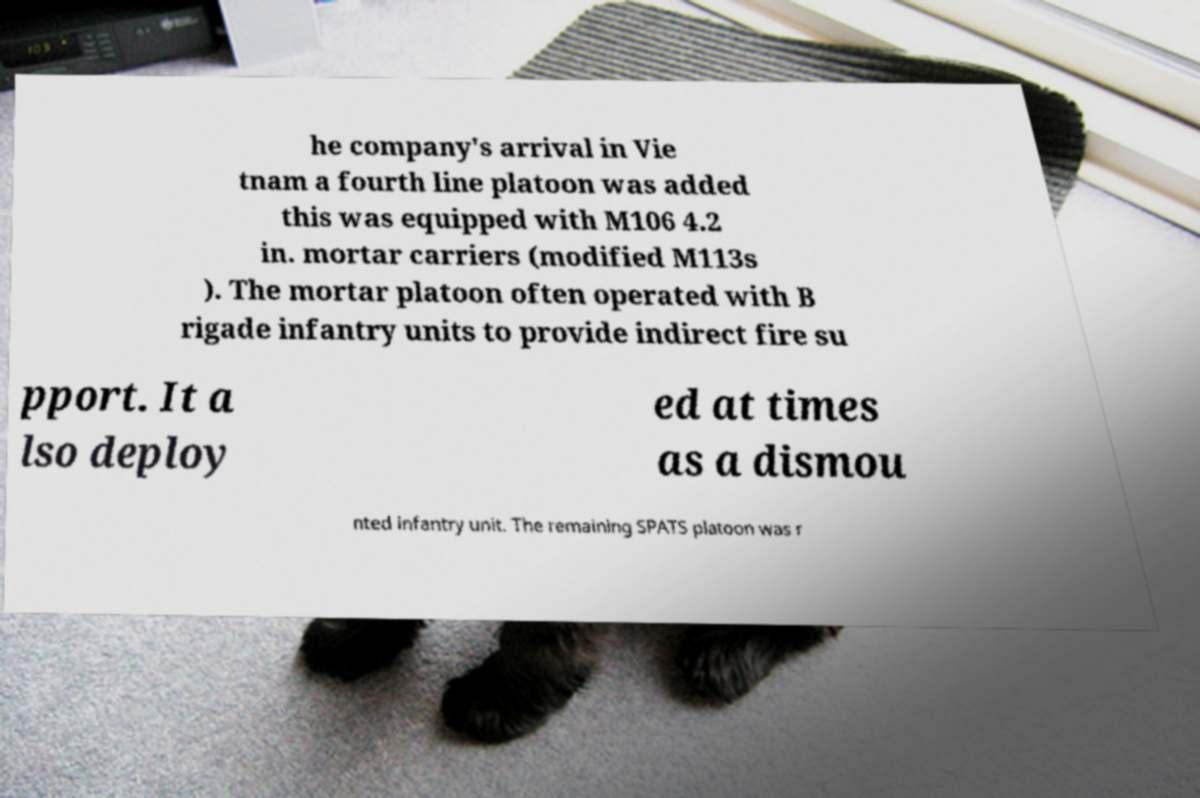I need the written content from this picture converted into text. Can you do that? he company's arrival in Vie tnam a fourth line platoon was added this was equipped with M106 4.2 in. mortar carriers (modified M113s ). The mortar platoon often operated with B rigade infantry units to provide indirect fire su pport. It a lso deploy ed at times as a dismou nted infantry unit. The remaining SPATS platoon was r 